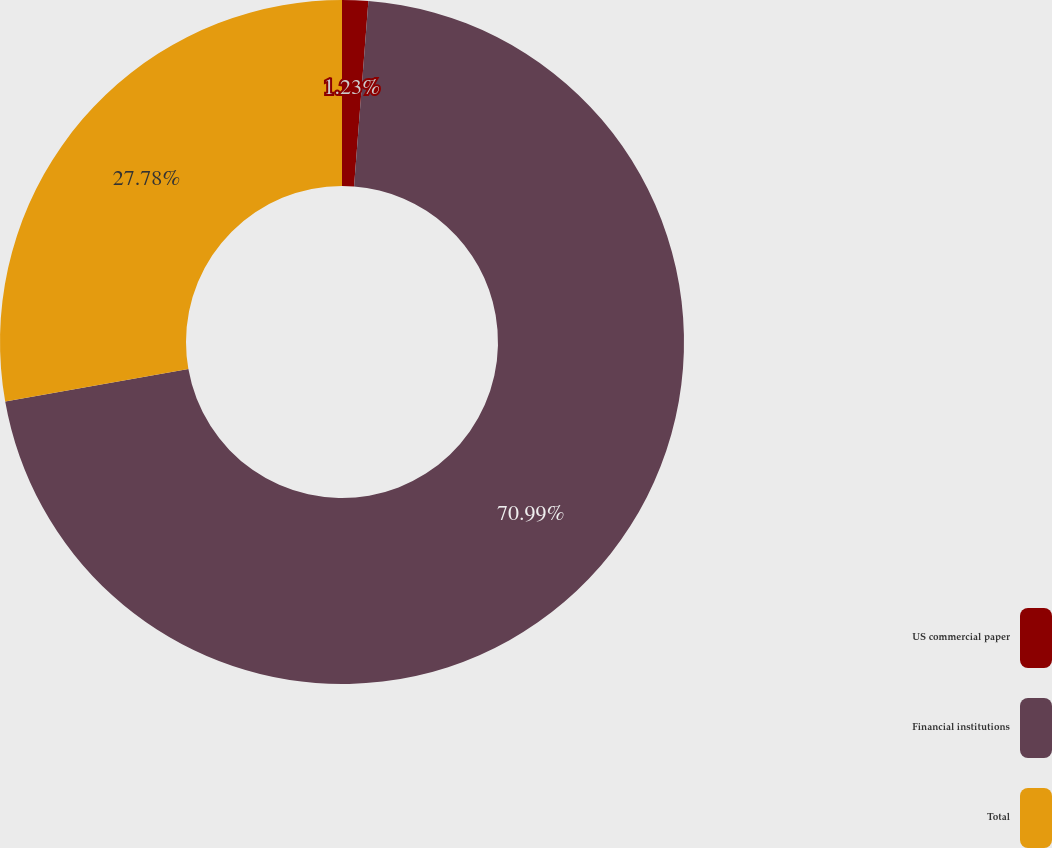Convert chart to OTSL. <chart><loc_0><loc_0><loc_500><loc_500><pie_chart><fcel>US commercial paper<fcel>Financial institutions<fcel>Total<nl><fcel>1.23%<fcel>70.99%<fcel>27.78%<nl></chart> 